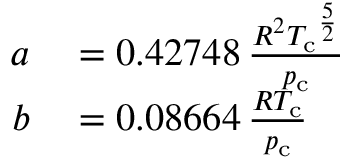Convert formula to latex. <formula><loc_0><loc_0><loc_500><loc_500>\begin{array} { r l } { a } & = 0 . 4 2 7 4 8 \, { \frac { R ^ { 2 } { T _ { c } } ^ { \frac { 5 } { 2 } } } { p _ { c } } } } \\ { b } & = 0 . 0 8 6 6 4 \, { \frac { R T _ { c } } { p _ { c } } } } \end{array}</formula> 